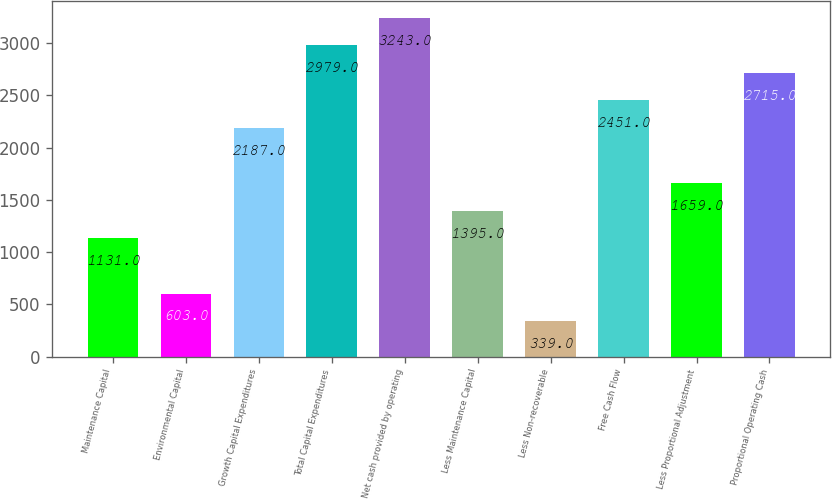Convert chart to OTSL. <chart><loc_0><loc_0><loc_500><loc_500><bar_chart><fcel>Maintenance Capital<fcel>Environmental Capital<fcel>Growth Capital Expenditures<fcel>Total Capital Expenditures<fcel>Net cash provided by operating<fcel>Less Maintenance Capital<fcel>Less Non-recoverable<fcel>Free Cash Flow<fcel>Less Proportional Adjustment<fcel>Proportional Operating Cash<nl><fcel>1131<fcel>603<fcel>2187<fcel>2979<fcel>3243<fcel>1395<fcel>339<fcel>2451<fcel>1659<fcel>2715<nl></chart> 